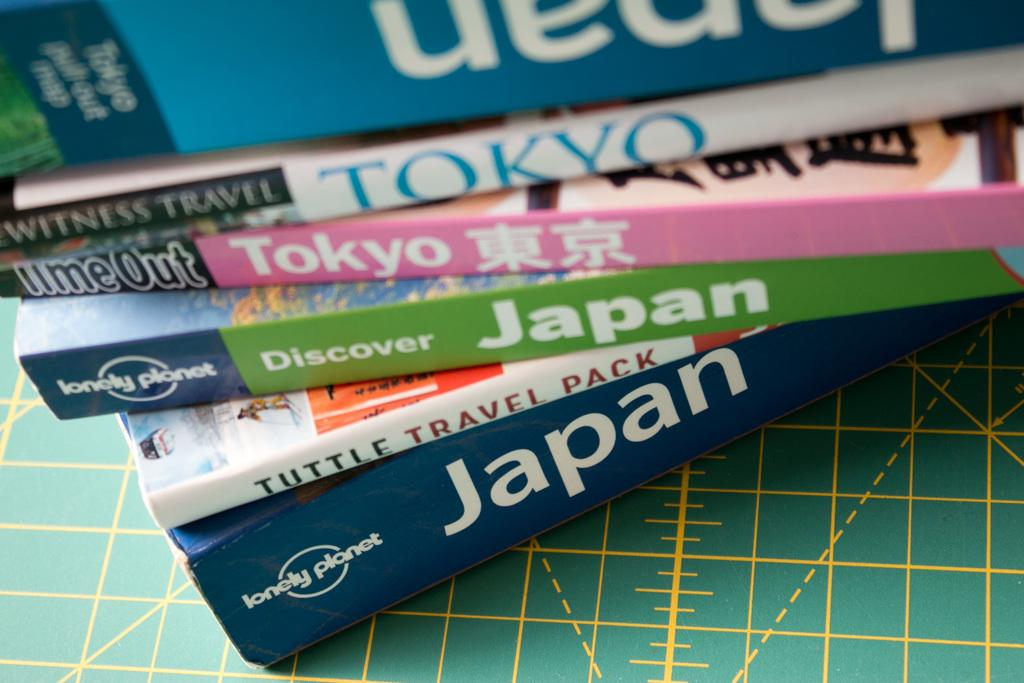Provide a one-sentence caption for the provided image. A stack of Tokyo and Japan books on a table. 